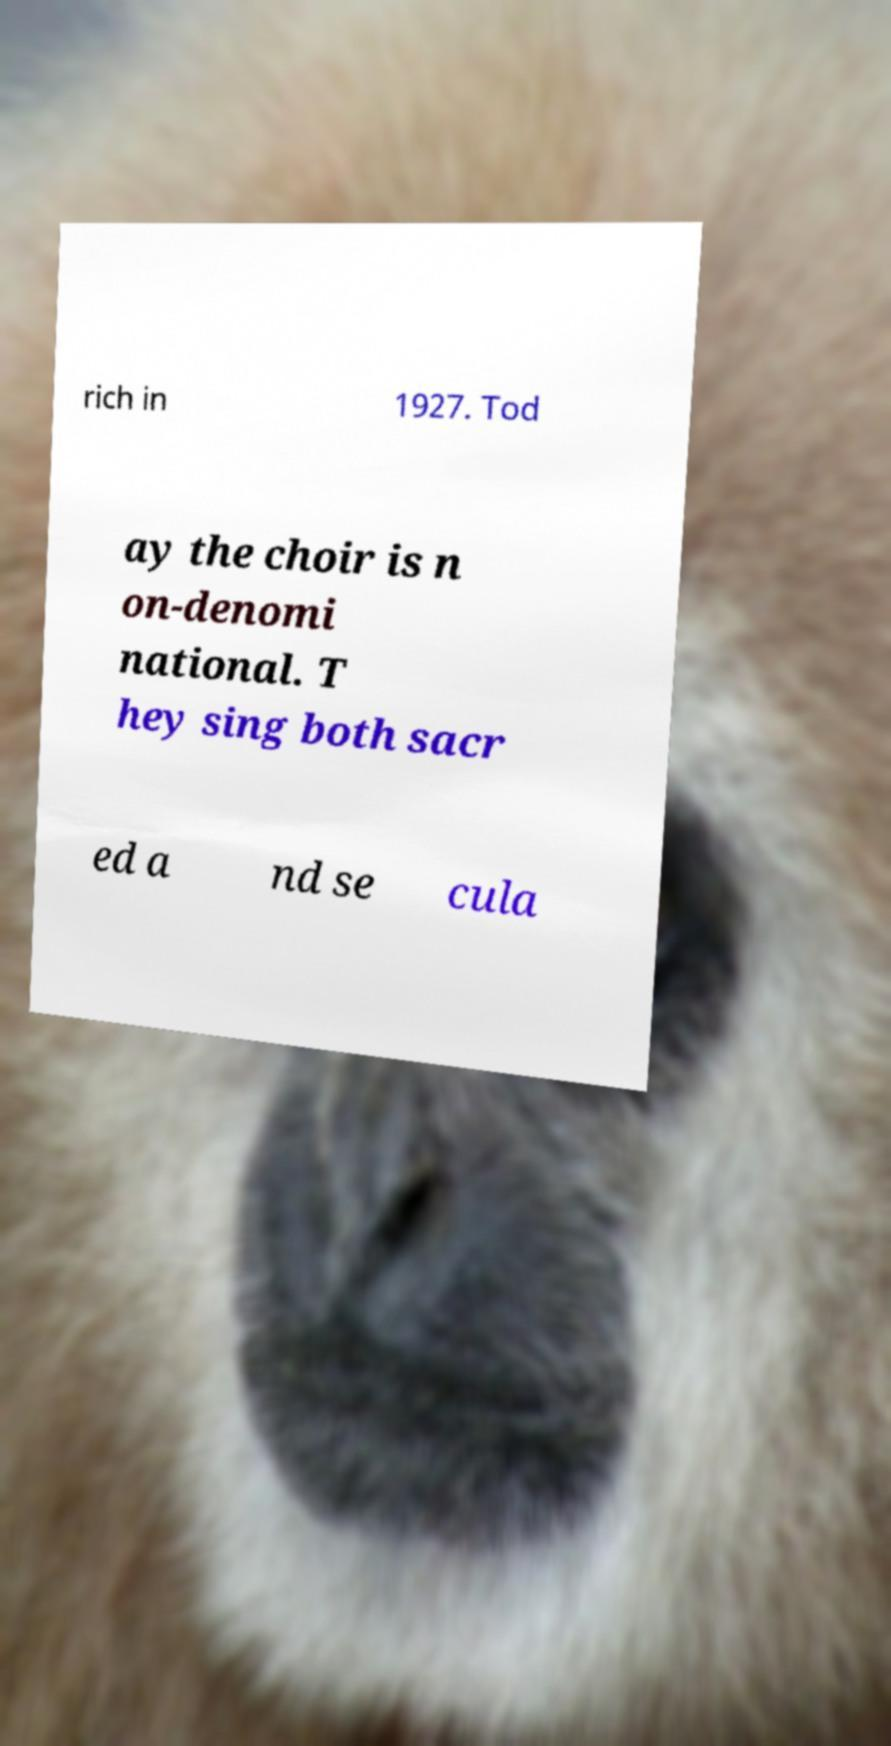There's text embedded in this image that I need extracted. Can you transcribe it verbatim? rich in 1927. Tod ay the choir is n on-denomi national. T hey sing both sacr ed a nd se cula 